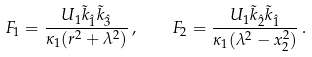<formula> <loc_0><loc_0><loc_500><loc_500>F _ { 1 } = \frac { U _ { 1 } { \tilde { k } } _ { \hat { 1 } } { \tilde { k } } _ { \hat { 3 } } } { \kappa _ { 1 } ( r ^ { 2 } + \lambda ^ { 2 } ) } \, , \quad F _ { 2 } = \frac { U _ { 1 } { \tilde { k } } _ { \hat { 2 } } { \tilde { k } } _ { \hat { 1 } } } { \kappa _ { 1 } ( \lambda ^ { 2 } - x _ { 2 } ^ { 2 } ) } \, .</formula> 